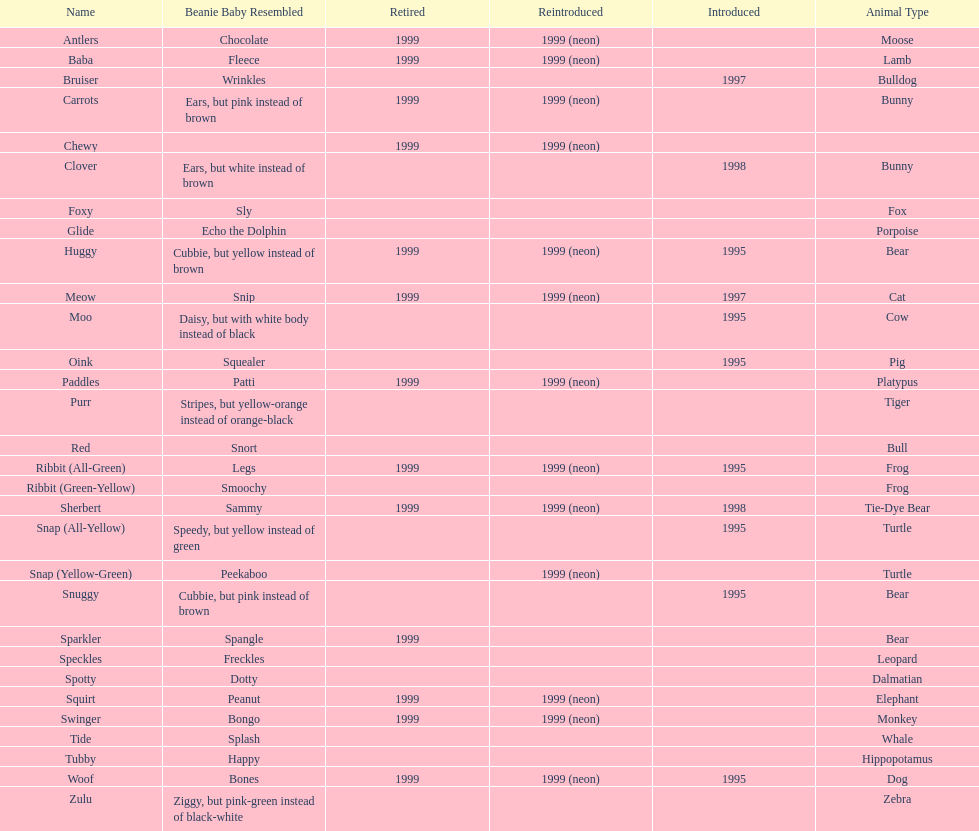What is the number of frog pillow pals? 2. 